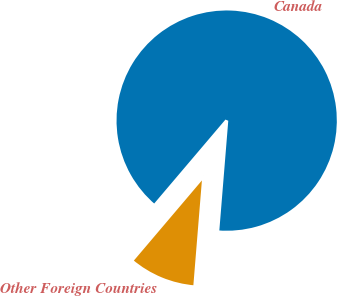Convert chart. <chart><loc_0><loc_0><loc_500><loc_500><pie_chart><fcel>Canada<fcel>Other Foreign Countries<nl><fcel>90.09%<fcel>9.91%<nl></chart> 